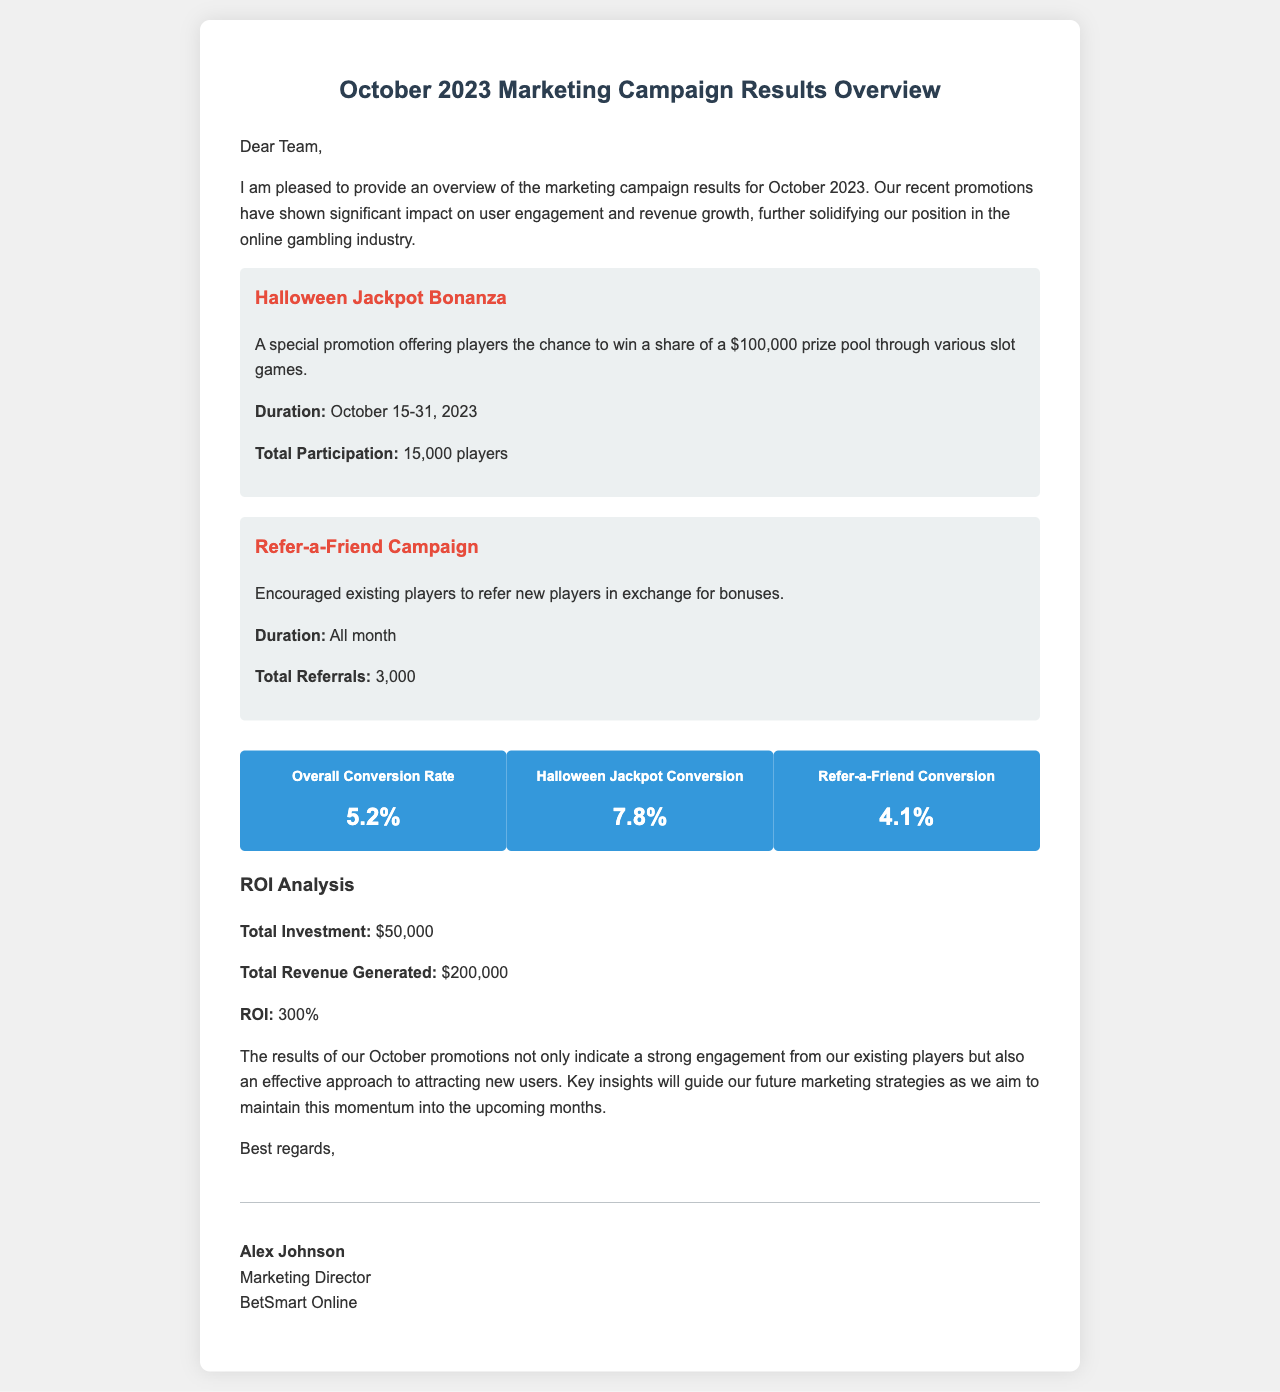what was the total investment for the campaign? The total investment is explicitly stated in the document as $50,000.
Answer: $50,000 what was the duration of the Halloween Jackpot Bonanza? The duration is specified in the document as October 15-31, 2023.
Answer: October 15-31, 2023 how many players participated in the Halloween promotion? The document mentions that total participation for the Halloween promotion was 15,000 players.
Answer: 15,000 players what is the ROI of the marketing campaign? The ROI is calculated and presented in the document as 300%.
Answer: 300% what is the conversion rate for the Refer-a-Friend campaign? The conversion rate for the Refer-a-Friend campaign is given as 4.1% in the document.
Answer: 4.1% who is the signatory of the letter? The document specifies that the letter is signed by Alex Johnson.
Answer: Alex Johnson what was the total revenue generated from the campaign? The total revenue generated is stated in the document as $200,000.
Answer: $200,000 which promotion had the highest conversion rate? The document states that the Halloween Jackpot had the highest conversion rate at 7.8%.
Answer: 7.8% how many referrals were made during the Refer-a-Friend campaign? The document indicates that there were a total of 3,000 referrals during the campaign.
Answer: 3,000 